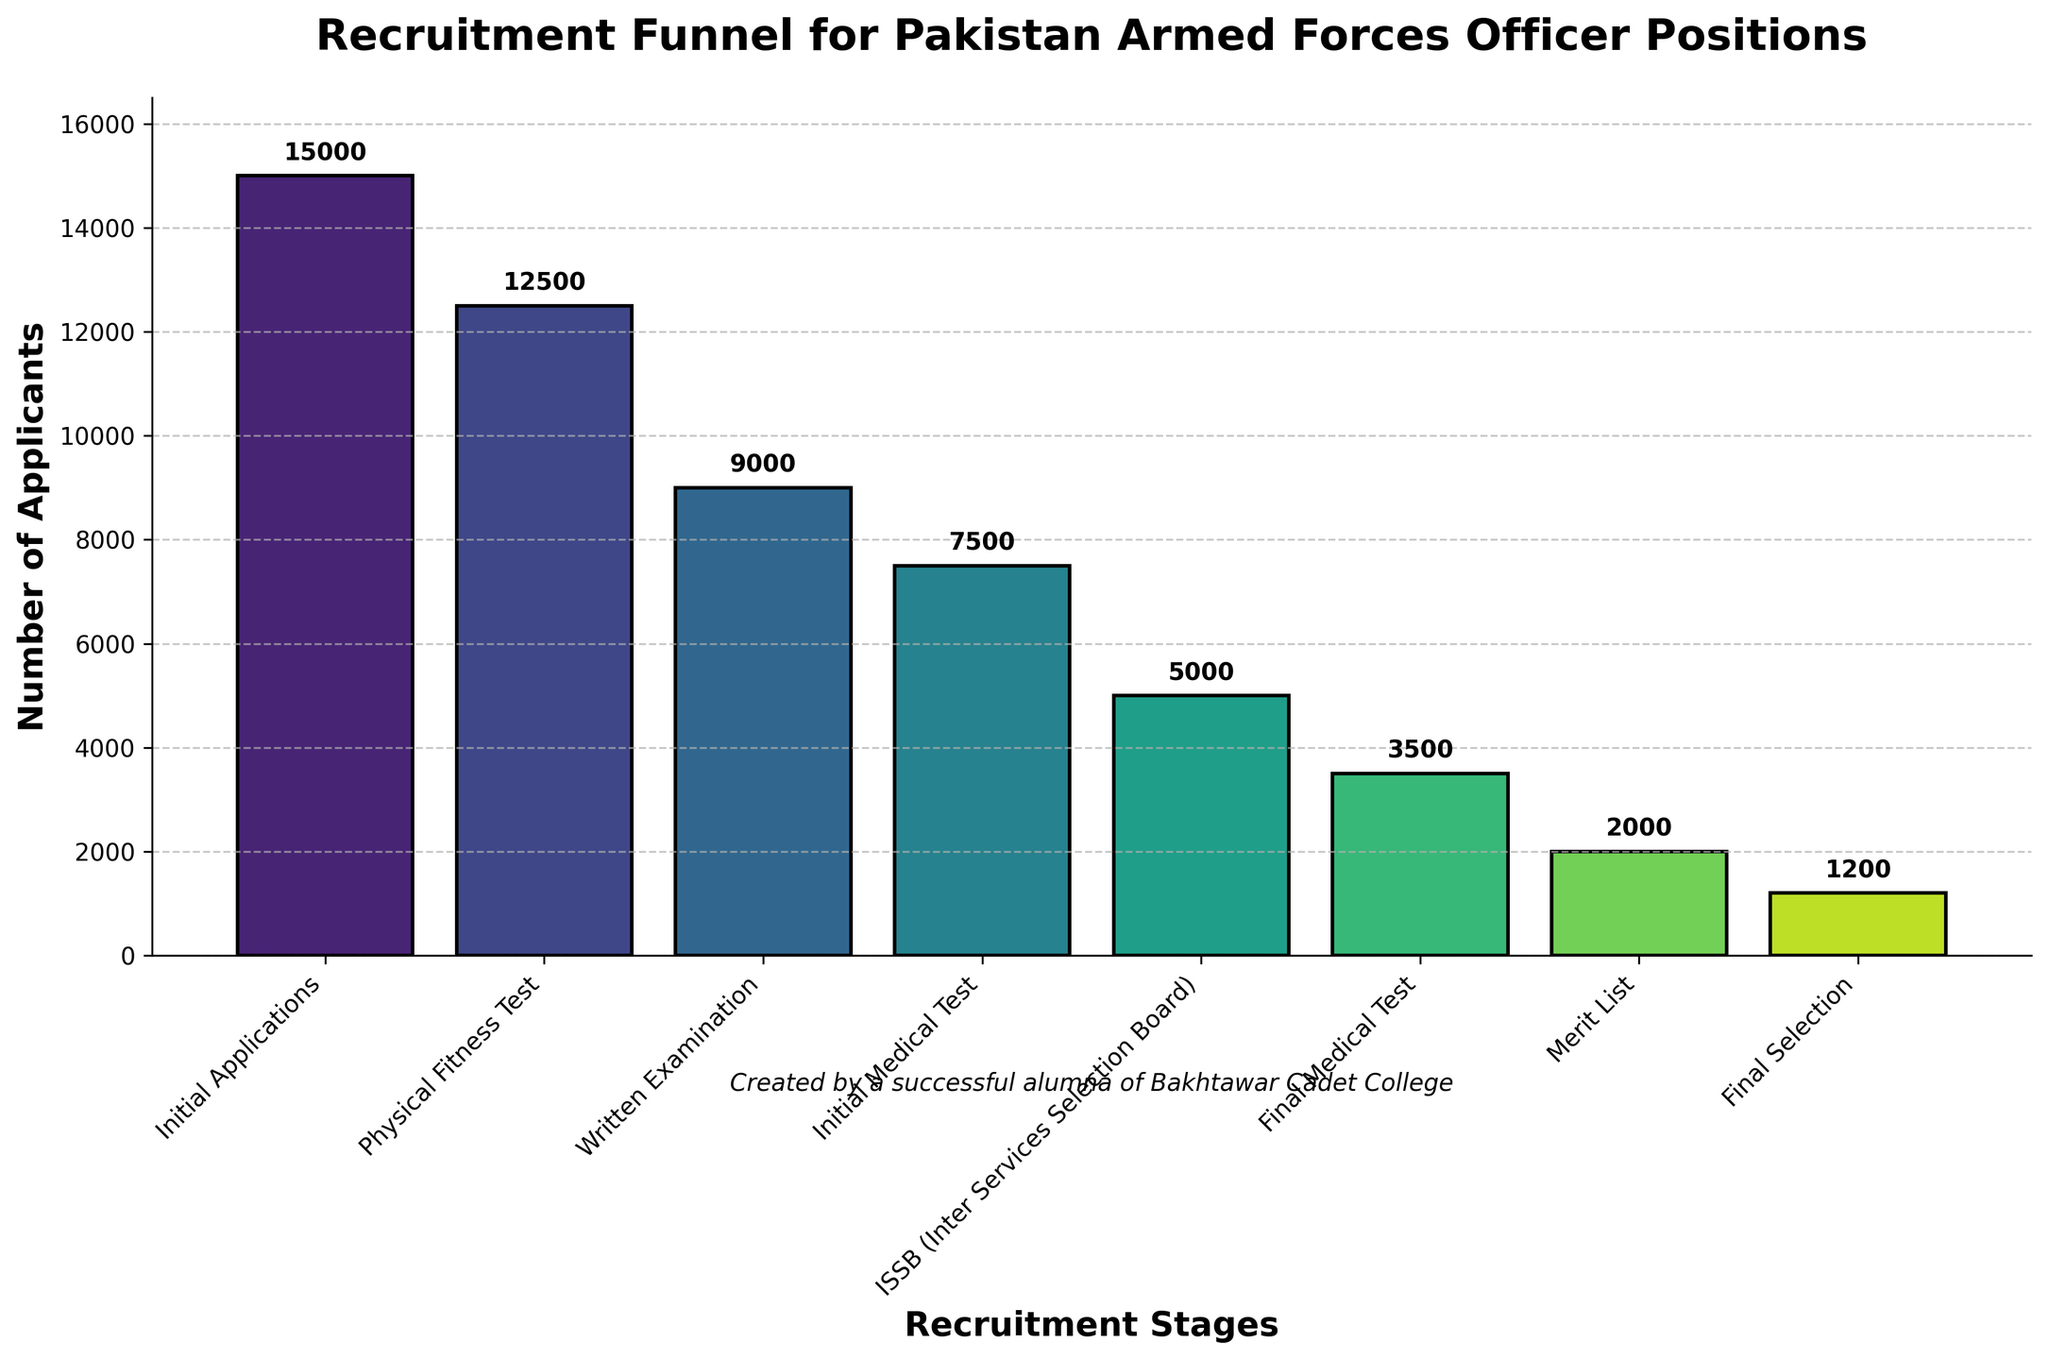What is the title of the figure? The title is usually found at the top center of the figure. It summarizes the main topic or focus of the chart, which in this case is "Recruitment Funnel for Pakistan Armed Forces Officer Positions."
Answer: Recruitment Funnel for Pakistan Armed Forces Officer Positions How many total recruitment stages are depicted in the funnel chart? By counting the number of stages listed on the x-axis, we find that there are eight distinct recruitment stages.
Answer: Eight What is the first stage in the recruitment process according to the funnel chart? The stages are listed in order from left to right on the x-axis. The first stage listed is "Initial Applications."
Answer: Initial Applications Which stage has the highest number of applicants? By observing the heights of the bars, the tallest bar represents "Initial Applications" stage, which has the highest number of applicants with 15,000.
Answer: Initial Applications How many applicants pass the ISSB stage? From the chart, locate the bar labeled "ISSB" and note the number annotated above it. It shows there are 5,000 applicants at this stage.
Answer: 5,000 What is the difference in the number of applicants between the Initial Medical Test and the Final Medical Test stages? The number of applicants for the Initial Medical Test is 7,500 and for the Final Medical Test is 3,500. Subtract the smaller number from the larger number to find the difference: 7,500 - 3,500 = 4,000.
Answer: 4,000 Which stage sees the largest drop in the number of applicants? To determine this, calculate the decrease in applicants between consecutive stages and identify the largest difference. From Initial Applications to Physical Fitness Test: 15,000 - 12,500 = 2,500. Physical Fitness Test to Written Examination: 12,500 - 9,000 = 3,500. Written Examination to Initial Medical Test: 9,000 - 7,500 = 1,500. Initial Medical Test to ISSB: 7,500 - 5,000 = 2,500. ISSB to Final Medical Test: 5,000 - 3,500 = 1,500. Final Medical Test to Merit List: 3,500 - 2,000 = 1,500. Merit List to Final Selection: 2,000 - 1,200 = 800. The largest drop is from Physical Fitness Test to Written Examination with a difference of 3,500.
Answer: Physical Fitness Test to Written Examination What percentage of the initial applicants make it to the Final Selection stage? There are 15,000 applicants in the Initial Applications stage, and 1,200 applicants in the Final Selection stage. To calculate the percentage: (1,200 / 15,000) * 100 = 8%.
Answer: 8% Which stage follows the Written Examination in the recruitment process? Following the order of stages from left to right on the x-axis, "Initial Medical Test" comes after "Written Examination."
Answer: Initial Medical Test 